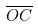<formula> <loc_0><loc_0><loc_500><loc_500>\overline { O C }</formula> 